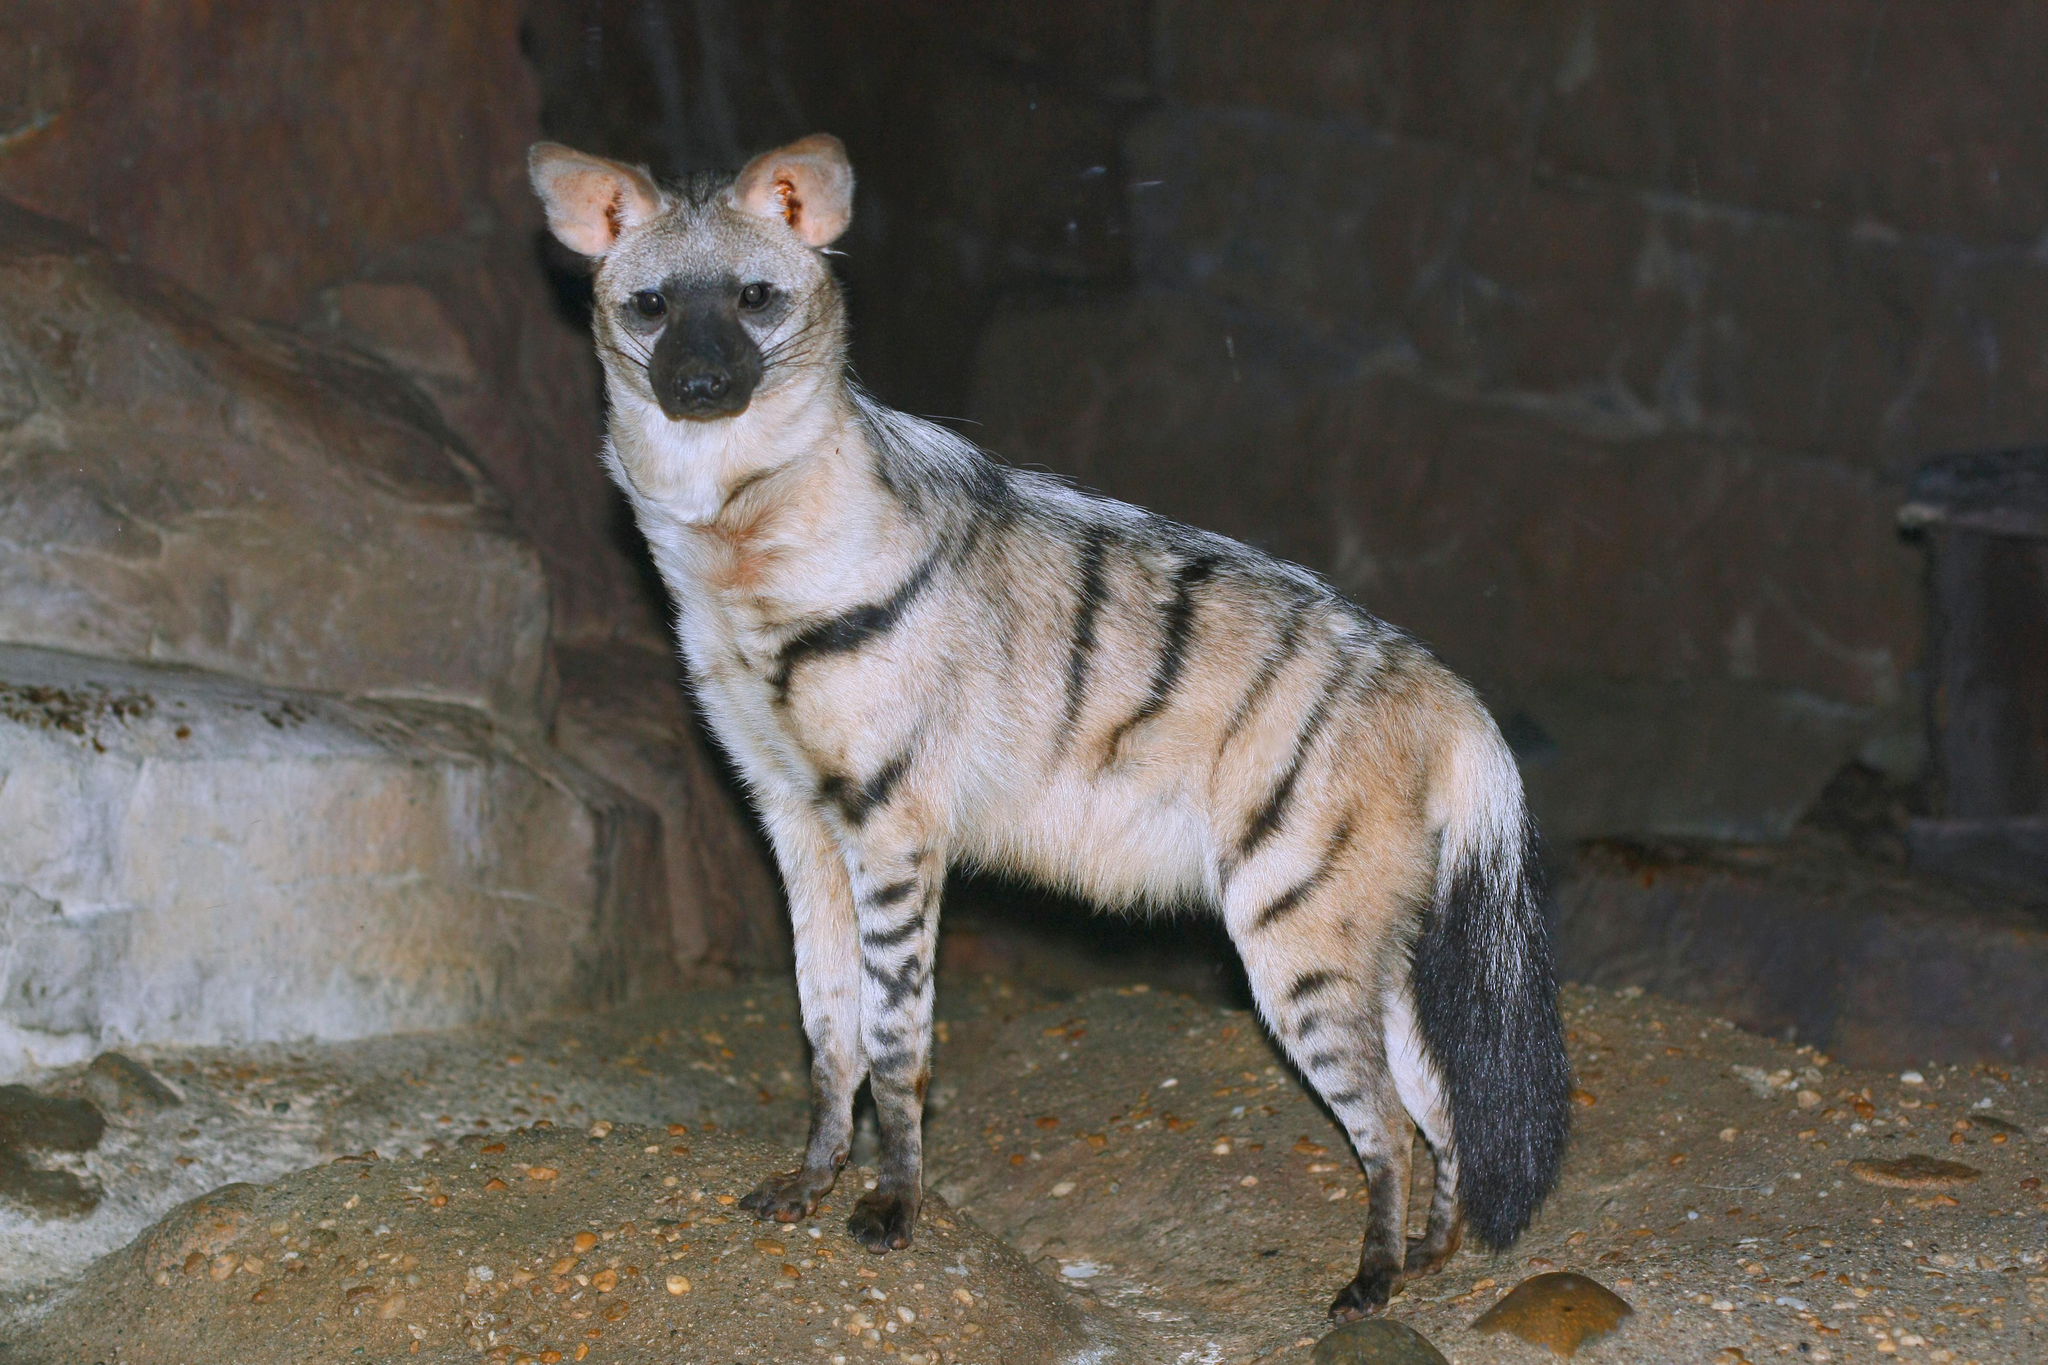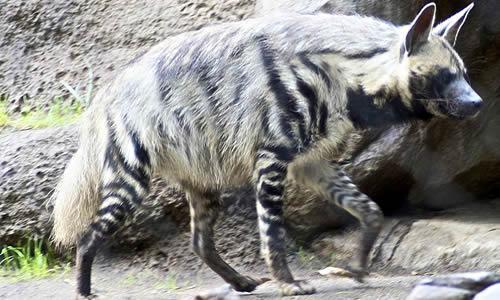The first image is the image on the left, the second image is the image on the right. Assess this claim about the two images: "Two hyenas are standing and facing opposite each other.". Correct or not? Answer yes or no. Yes. The first image is the image on the left, the second image is the image on the right. Given the left and right images, does the statement "1 dog has a paw that is not touching the ground." hold true? Answer yes or no. Yes. 